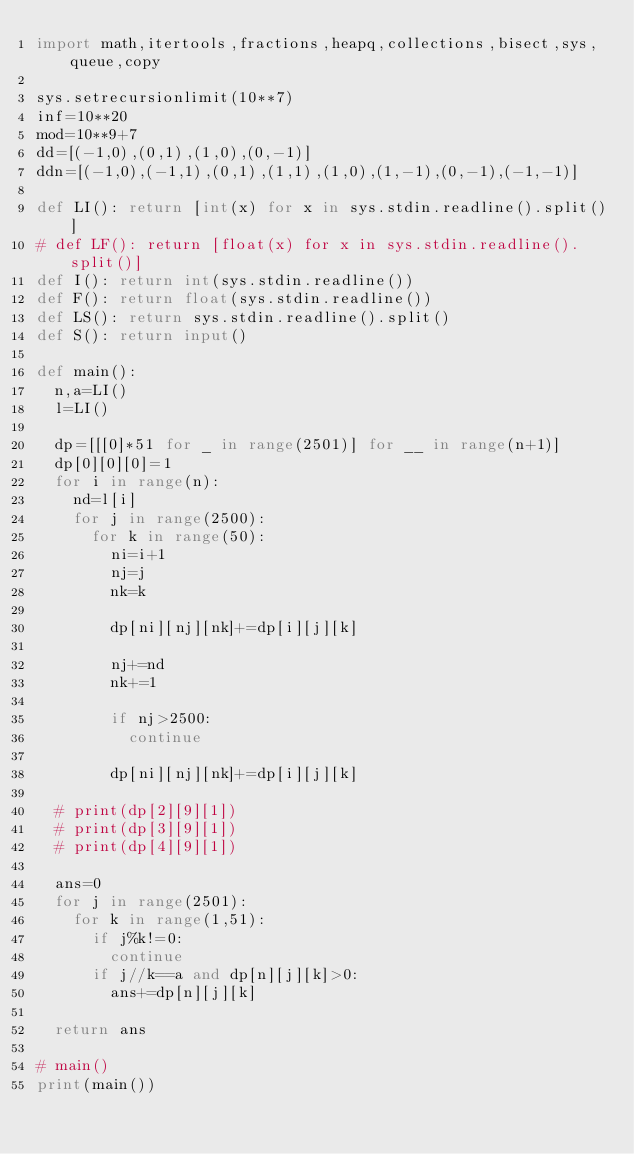<code> <loc_0><loc_0><loc_500><loc_500><_Python_>import math,itertools,fractions,heapq,collections,bisect,sys,queue,copy

sys.setrecursionlimit(10**7)
inf=10**20
mod=10**9+7
dd=[(-1,0),(0,1),(1,0),(0,-1)]
ddn=[(-1,0),(-1,1),(0,1),(1,1),(1,0),(1,-1),(0,-1),(-1,-1)]

def LI(): return [int(x) for x in sys.stdin.readline().split()]
# def LF(): return [float(x) for x in sys.stdin.readline().split()]
def I(): return int(sys.stdin.readline())
def F(): return float(sys.stdin.readline())
def LS(): return sys.stdin.readline().split()
def S(): return input()

def main():
  n,a=LI()
  l=LI()

  dp=[[[0]*51 for _ in range(2501)] for __ in range(n+1)]
  dp[0][0][0]=1
  for i in range(n):
    nd=l[i]
    for j in range(2500):
      for k in range(50):
        ni=i+1
        nj=j
        nk=k

        dp[ni][nj][nk]+=dp[i][j][k]

        nj+=nd
        nk+=1

        if nj>2500:
          continue

        dp[ni][nj][nk]+=dp[i][j][k]

  # print(dp[2][9][1])
  # print(dp[3][9][1])
  # print(dp[4][9][1])

  ans=0
  for j in range(2501):
    for k in range(1,51):
      if j%k!=0:
        continue
      if j//k==a and dp[n][j][k]>0:
        ans+=dp[n][j][k]

  return ans

# main()
print(main())
</code> 